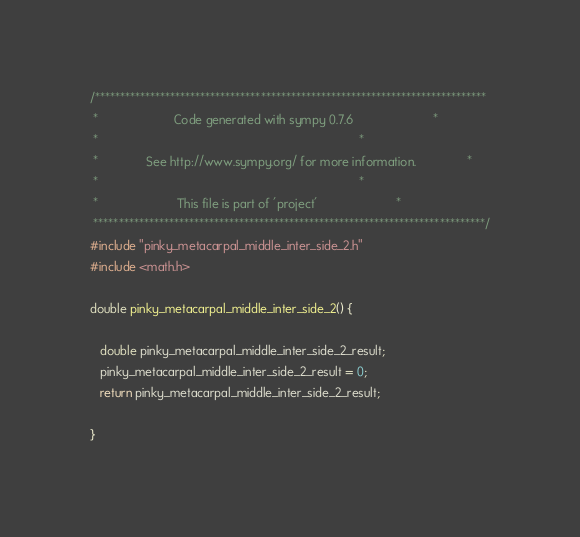<code> <loc_0><loc_0><loc_500><loc_500><_C_>/******************************************************************************
 *                      Code generated with sympy 0.7.6                       *
 *                                                                            *
 *              See http://www.sympy.org/ for more information.               *
 *                                                                            *
 *                       This file is part of 'project'                       *
 ******************************************************************************/
#include "pinky_metacarpal_middle_inter_side_2.h"
#include <math.h>

double pinky_metacarpal_middle_inter_side_2() {

   double pinky_metacarpal_middle_inter_side_2_result;
   pinky_metacarpal_middle_inter_side_2_result = 0;
   return pinky_metacarpal_middle_inter_side_2_result;

}
</code> 